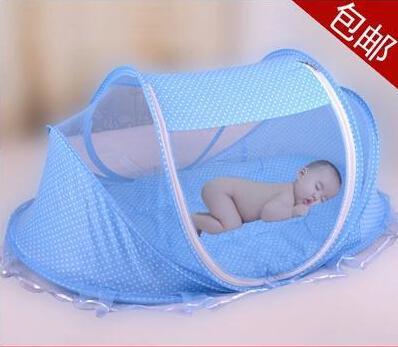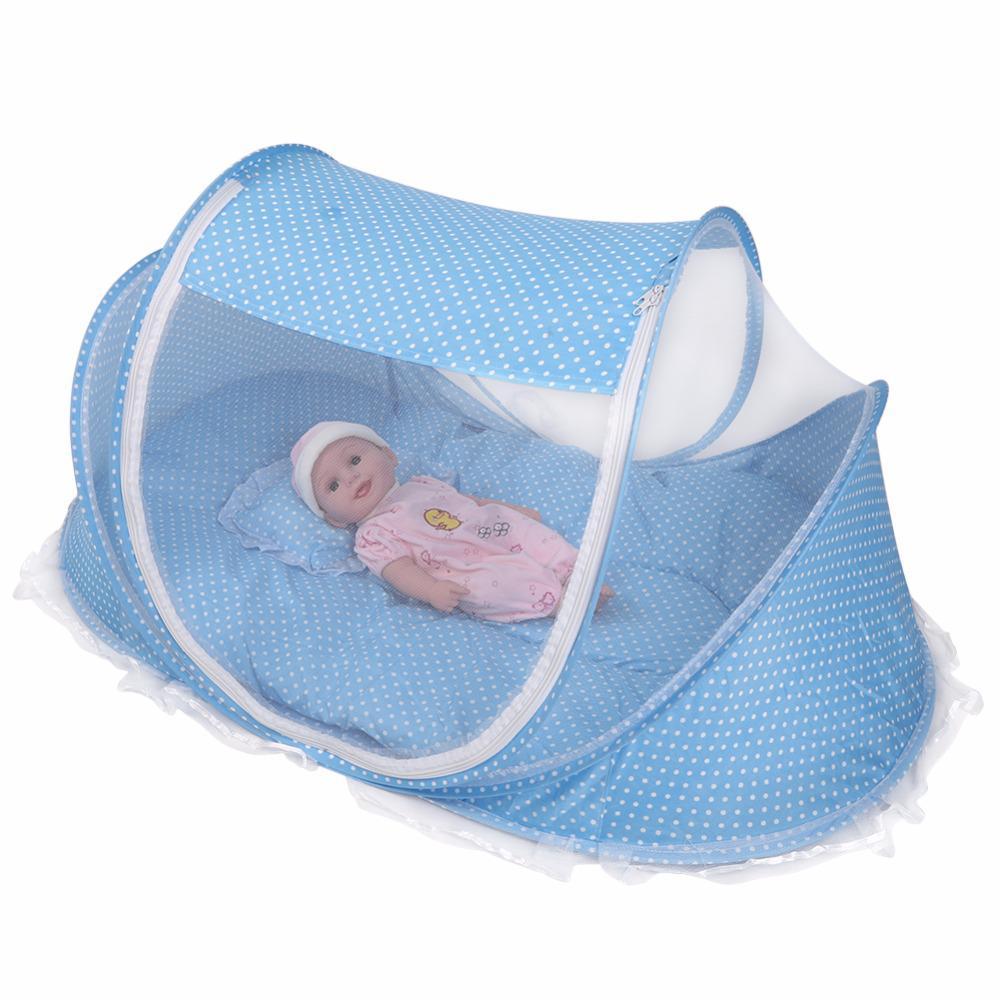The first image is the image on the left, the second image is the image on the right. For the images displayed, is the sentence "There is a stuffed animal in the left image." factually correct? Answer yes or no. No. The first image is the image on the left, the second image is the image on the right. Examine the images to the left and right. Is the description "There are two blue canopies with at least one zip tent." accurate? Answer yes or no. Yes. 